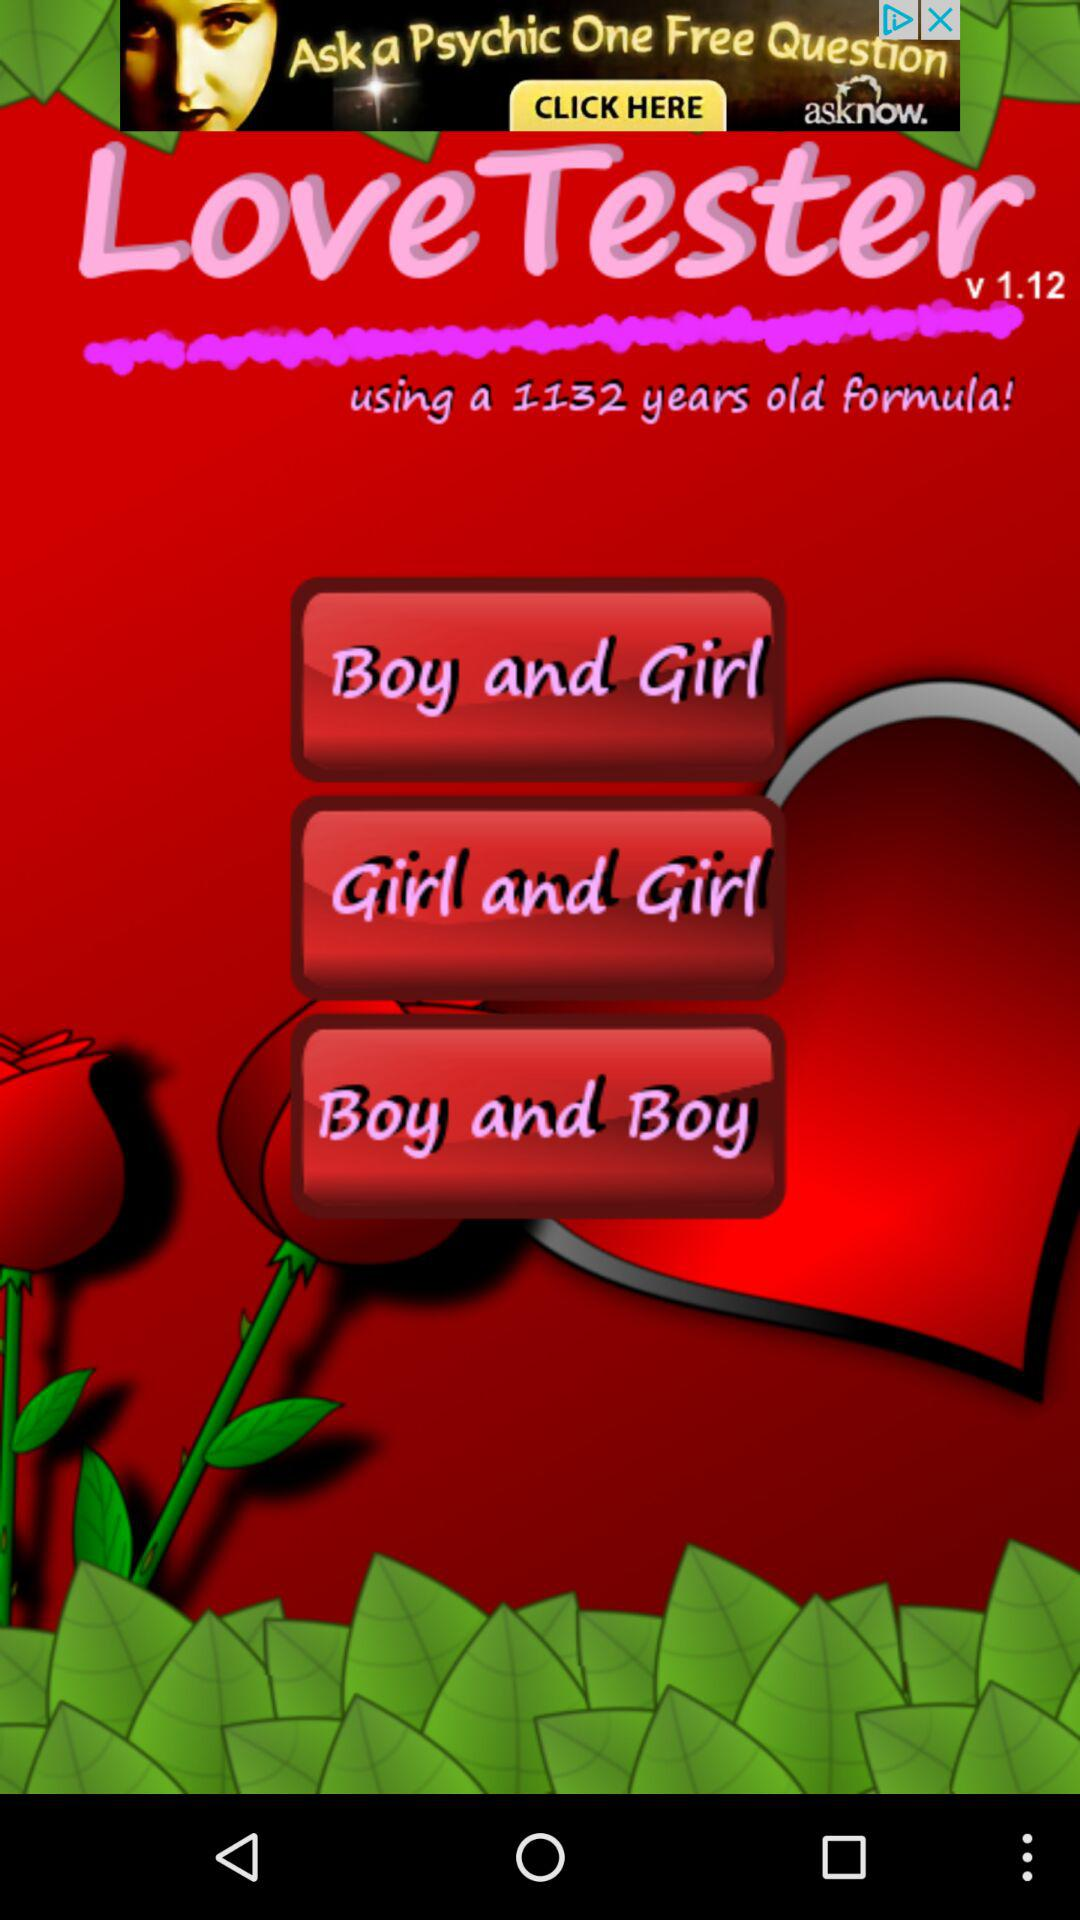What is the version? The version is v1.12. 